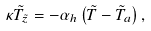Convert formula to latex. <formula><loc_0><loc_0><loc_500><loc_500>\kappa \tilde { T } _ { \tilde { z } } = - \alpha _ { h } \left ( \tilde { T } - \tilde { T } _ { a } \right ) ,</formula> 